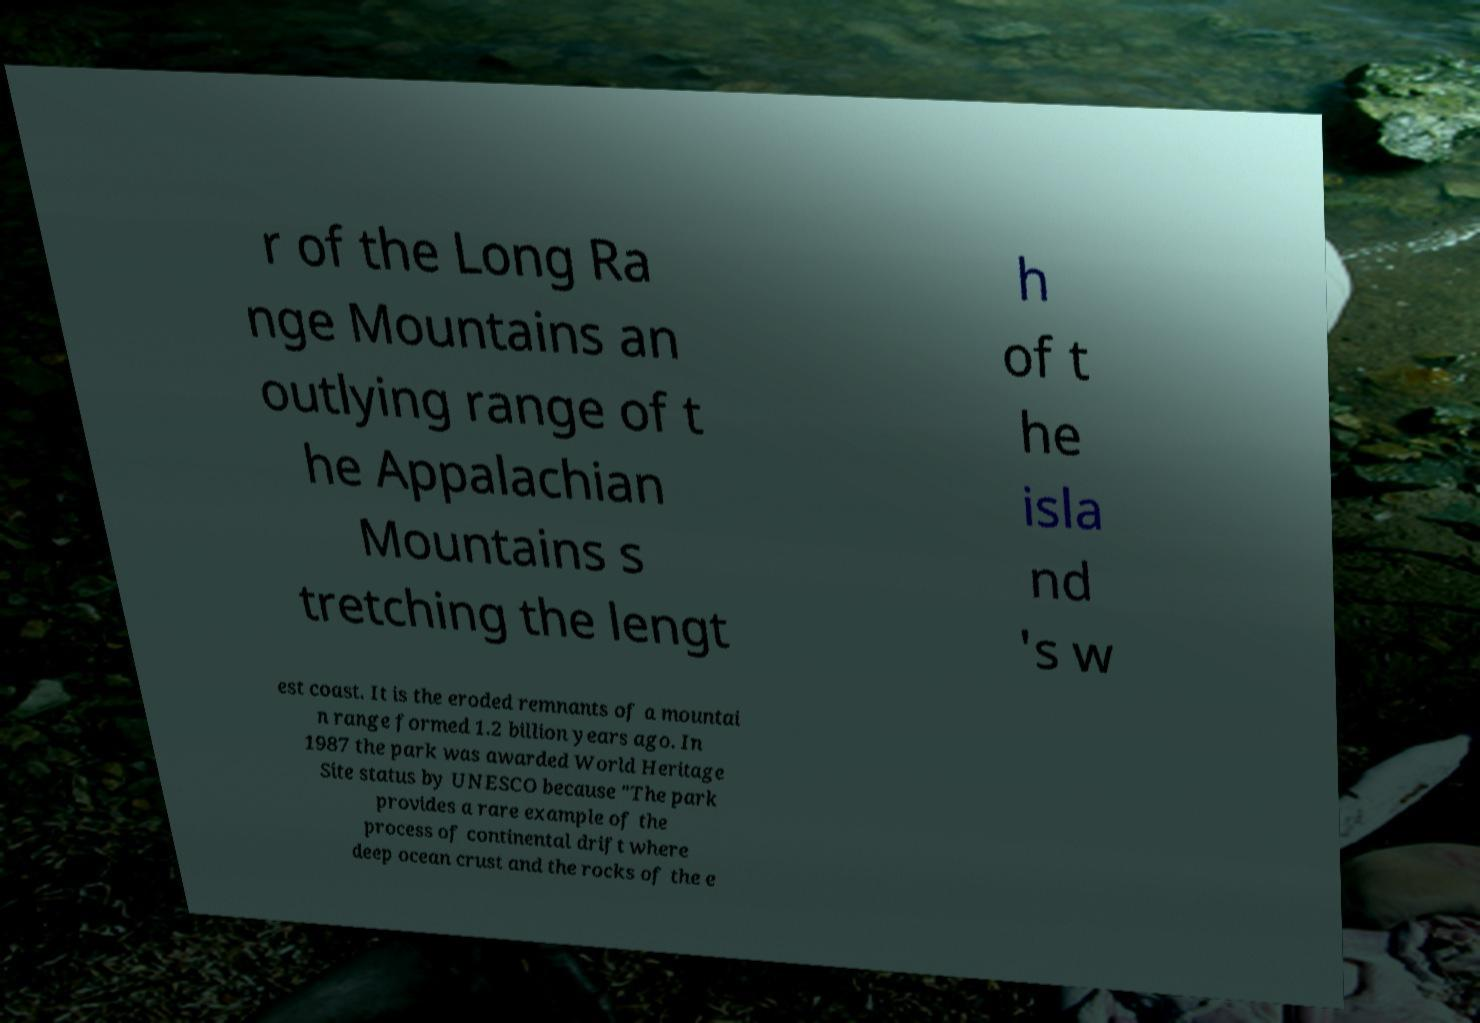Please identify and transcribe the text found in this image. r of the Long Ra nge Mountains an outlying range of t he Appalachian Mountains s tretching the lengt h of t he isla nd 's w est coast. It is the eroded remnants of a mountai n range formed 1.2 billion years ago. In 1987 the park was awarded World Heritage Site status by UNESCO because "The park provides a rare example of the process of continental drift where deep ocean crust and the rocks of the e 